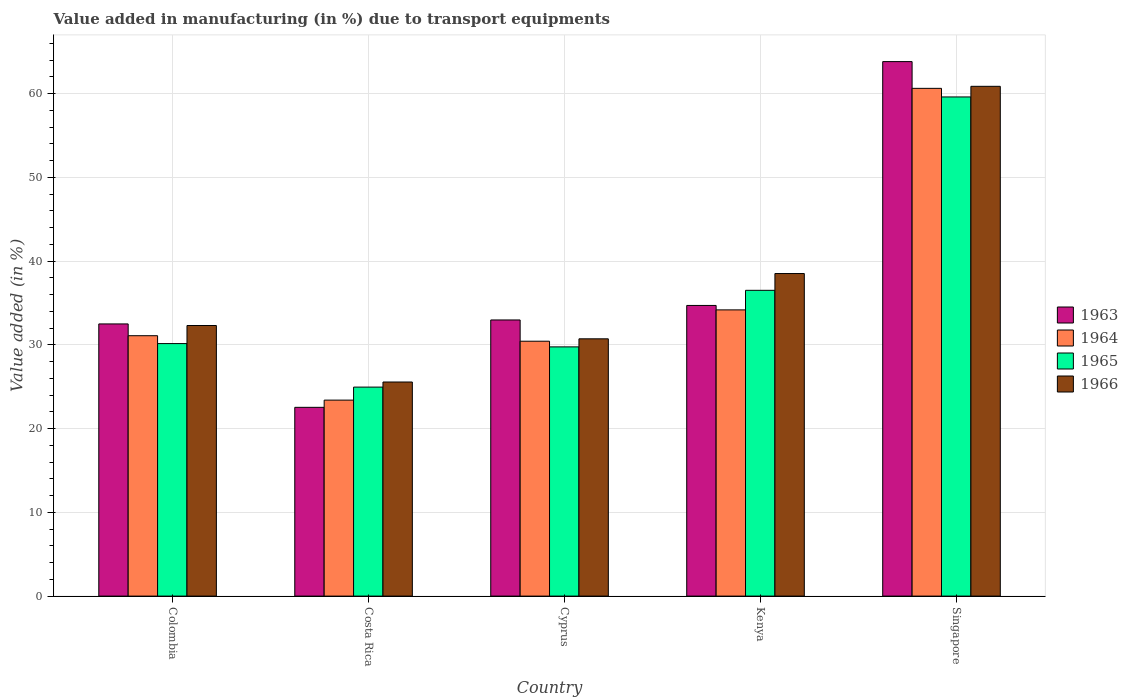How many different coloured bars are there?
Your answer should be very brief. 4. Are the number of bars per tick equal to the number of legend labels?
Provide a short and direct response. Yes. How many bars are there on the 3rd tick from the left?
Your answer should be very brief. 4. How many bars are there on the 2nd tick from the right?
Offer a very short reply. 4. What is the label of the 3rd group of bars from the left?
Your answer should be compact. Cyprus. What is the percentage of value added in manufacturing due to transport equipments in 1965 in Costa Rica?
Offer a terse response. 24.95. Across all countries, what is the maximum percentage of value added in manufacturing due to transport equipments in 1963?
Make the answer very short. 63.81. Across all countries, what is the minimum percentage of value added in manufacturing due to transport equipments in 1964?
Provide a succinct answer. 23.4. In which country was the percentage of value added in manufacturing due to transport equipments in 1963 maximum?
Provide a short and direct response. Singapore. What is the total percentage of value added in manufacturing due to transport equipments in 1966 in the graph?
Provide a succinct answer. 187.95. What is the difference between the percentage of value added in manufacturing due to transport equipments in 1966 in Costa Rica and that in Kenya?
Provide a short and direct response. -12.95. What is the difference between the percentage of value added in manufacturing due to transport equipments in 1963 in Kenya and the percentage of value added in manufacturing due to transport equipments in 1966 in Singapore?
Provide a short and direct response. -26.16. What is the average percentage of value added in manufacturing due to transport equipments in 1964 per country?
Provide a short and direct response. 35.94. What is the difference between the percentage of value added in manufacturing due to transport equipments of/in 1966 and percentage of value added in manufacturing due to transport equipments of/in 1964 in Costa Rica?
Keep it short and to the point. 2.16. What is the ratio of the percentage of value added in manufacturing due to transport equipments in 1964 in Cyprus to that in Kenya?
Offer a very short reply. 0.89. Is the difference between the percentage of value added in manufacturing due to transport equipments in 1966 in Cyprus and Singapore greater than the difference between the percentage of value added in manufacturing due to transport equipments in 1964 in Cyprus and Singapore?
Your answer should be compact. Yes. What is the difference between the highest and the second highest percentage of value added in manufacturing due to transport equipments in 1963?
Ensure brevity in your answer.  -1.73. What is the difference between the highest and the lowest percentage of value added in manufacturing due to transport equipments in 1963?
Your answer should be compact. 41.28. Is the sum of the percentage of value added in manufacturing due to transport equipments in 1963 in Colombia and Costa Rica greater than the maximum percentage of value added in manufacturing due to transport equipments in 1965 across all countries?
Give a very brief answer. No. What does the 4th bar from the left in Costa Rica represents?
Your response must be concise. 1966. What does the 2nd bar from the right in Colombia represents?
Offer a terse response. 1965. How many bars are there?
Provide a short and direct response. 20. Are all the bars in the graph horizontal?
Keep it short and to the point. No. How many countries are there in the graph?
Offer a very short reply. 5. What is the difference between two consecutive major ticks on the Y-axis?
Provide a succinct answer. 10. Are the values on the major ticks of Y-axis written in scientific E-notation?
Provide a succinct answer. No. Does the graph contain any zero values?
Your answer should be very brief. No. Where does the legend appear in the graph?
Ensure brevity in your answer.  Center right. How many legend labels are there?
Make the answer very short. 4. How are the legend labels stacked?
Provide a succinct answer. Vertical. What is the title of the graph?
Provide a succinct answer. Value added in manufacturing (in %) due to transport equipments. Does "2013" appear as one of the legend labels in the graph?
Your response must be concise. No. What is the label or title of the Y-axis?
Offer a terse response. Value added (in %). What is the Value added (in %) of 1963 in Colombia?
Provide a succinct answer. 32.49. What is the Value added (in %) in 1964 in Colombia?
Offer a very short reply. 31.09. What is the Value added (in %) in 1965 in Colombia?
Ensure brevity in your answer.  30.15. What is the Value added (in %) of 1966 in Colombia?
Ensure brevity in your answer.  32.3. What is the Value added (in %) of 1963 in Costa Rica?
Offer a terse response. 22.53. What is the Value added (in %) in 1964 in Costa Rica?
Your answer should be compact. 23.4. What is the Value added (in %) of 1965 in Costa Rica?
Make the answer very short. 24.95. What is the Value added (in %) of 1966 in Costa Rica?
Ensure brevity in your answer.  25.56. What is the Value added (in %) of 1963 in Cyprus?
Give a very brief answer. 32.97. What is the Value added (in %) in 1964 in Cyprus?
Your answer should be compact. 30.43. What is the Value added (in %) in 1965 in Cyprus?
Offer a terse response. 29.75. What is the Value added (in %) of 1966 in Cyprus?
Keep it short and to the point. 30.72. What is the Value added (in %) of 1963 in Kenya?
Ensure brevity in your answer.  34.7. What is the Value added (in %) in 1964 in Kenya?
Make the answer very short. 34.17. What is the Value added (in %) of 1965 in Kenya?
Your answer should be compact. 36.5. What is the Value added (in %) in 1966 in Kenya?
Make the answer very short. 38.51. What is the Value added (in %) of 1963 in Singapore?
Make the answer very short. 63.81. What is the Value added (in %) of 1964 in Singapore?
Make the answer very short. 60.62. What is the Value added (in %) in 1965 in Singapore?
Provide a succinct answer. 59.59. What is the Value added (in %) of 1966 in Singapore?
Ensure brevity in your answer.  60.86. Across all countries, what is the maximum Value added (in %) of 1963?
Provide a short and direct response. 63.81. Across all countries, what is the maximum Value added (in %) in 1964?
Your answer should be very brief. 60.62. Across all countries, what is the maximum Value added (in %) in 1965?
Your answer should be compact. 59.59. Across all countries, what is the maximum Value added (in %) in 1966?
Provide a short and direct response. 60.86. Across all countries, what is the minimum Value added (in %) of 1963?
Give a very brief answer. 22.53. Across all countries, what is the minimum Value added (in %) of 1964?
Offer a terse response. 23.4. Across all countries, what is the minimum Value added (in %) in 1965?
Your answer should be compact. 24.95. Across all countries, what is the minimum Value added (in %) in 1966?
Your answer should be compact. 25.56. What is the total Value added (in %) of 1963 in the graph?
Your answer should be very brief. 186.5. What is the total Value added (in %) of 1964 in the graph?
Offer a very short reply. 179.7. What is the total Value added (in %) of 1965 in the graph?
Ensure brevity in your answer.  180.94. What is the total Value added (in %) in 1966 in the graph?
Keep it short and to the point. 187.95. What is the difference between the Value added (in %) in 1963 in Colombia and that in Costa Rica?
Your answer should be very brief. 9.96. What is the difference between the Value added (in %) of 1964 in Colombia and that in Costa Rica?
Offer a terse response. 7.69. What is the difference between the Value added (in %) in 1965 in Colombia and that in Costa Rica?
Give a very brief answer. 5.2. What is the difference between the Value added (in %) in 1966 in Colombia and that in Costa Rica?
Keep it short and to the point. 6.74. What is the difference between the Value added (in %) in 1963 in Colombia and that in Cyprus?
Make the answer very short. -0.47. What is the difference between the Value added (in %) of 1964 in Colombia and that in Cyprus?
Your response must be concise. 0.66. What is the difference between the Value added (in %) in 1965 in Colombia and that in Cyprus?
Offer a terse response. 0.39. What is the difference between the Value added (in %) of 1966 in Colombia and that in Cyprus?
Offer a very short reply. 1.59. What is the difference between the Value added (in %) in 1963 in Colombia and that in Kenya?
Make the answer very short. -2.21. What is the difference between the Value added (in %) of 1964 in Colombia and that in Kenya?
Make the answer very short. -3.08. What is the difference between the Value added (in %) of 1965 in Colombia and that in Kenya?
Your answer should be very brief. -6.36. What is the difference between the Value added (in %) of 1966 in Colombia and that in Kenya?
Your answer should be compact. -6.2. What is the difference between the Value added (in %) of 1963 in Colombia and that in Singapore?
Give a very brief answer. -31.32. What is the difference between the Value added (in %) in 1964 in Colombia and that in Singapore?
Your response must be concise. -29.53. What is the difference between the Value added (in %) in 1965 in Colombia and that in Singapore?
Ensure brevity in your answer.  -29.45. What is the difference between the Value added (in %) in 1966 in Colombia and that in Singapore?
Provide a succinct answer. -28.56. What is the difference between the Value added (in %) of 1963 in Costa Rica and that in Cyprus?
Ensure brevity in your answer.  -10.43. What is the difference between the Value added (in %) in 1964 in Costa Rica and that in Cyprus?
Your answer should be compact. -7.03. What is the difference between the Value added (in %) of 1965 in Costa Rica and that in Cyprus?
Your answer should be compact. -4.8. What is the difference between the Value added (in %) of 1966 in Costa Rica and that in Cyprus?
Provide a short and direct response. -5.16. What is the difference between the Value added (in %) in 1963 in Costa Rica and that in Kenya?
Give a very brief answer. -12.17. What is the difference between the Value added (in %) in 1964 in Costa Rica and that in Kenya?
Your answer should be compact. -10.77. What is the difference between the Value added (in %) of 1965 in Costa Rica and that in Kenya?
Ensure brevity in your answer.  -11.55. What is the difference between the Value added (in %) of 1966 in Costa Rica and that in Kenya?
Provide a succinct answer. -12.95. What is the difference between the Value added (in %) of 1963 in Costa Rica and that in Singapore?
Keep it short and to the point. -41.28. What is the difference between the Value added (in %) in 1964 in Costa Rica and that in Singapore?
Ensure brevity in your answer.  -37.22. What is the difference between the Value added (in %) in 1965 in Costa Rica and that in Singapore?
Provide a short and direct response. -34.64. What is the difference between the Value added (in %) in 1966 in Costa Rica and that in Singapore?
Offer a terse response. -35.3. What is the difference between the Value added (in %) in 1963 in Cyprus and that in Kenya?
Make the answer very short. -1.73. What is the difference between the Value added (in %) in 1964 in Cyprus and that in Kenya?
Offer a very short reply. -3.74. What is the difference between the Value added (in %) of 1965 in Cyprus and that in Kenya?
Make the answer very short. -6.75. What is the difference between the Value added (in %) of 1966 in Cyprus and that in Kenya?
Provide a succinct answer. -7.79. What is the difference between the Value added (in %) in 1963 in Cyprus and that in Singapore?
Provide a succinct answer. -30.84. What is the difference between the Value added (in %) in 1964 in Cyprus and that in Singapore?
Offer a very short reply. -30.19. What is the difference between the Value added (in %) of 1965 in Cyprus and that in Singapore?
Provide a short and direct response. -29.84. What is the difference between the Value added (in %) in 1966 in Cyprus and that in Singapore?
Provide a succinct answer. -30.14. What is the difference between the Value added (in %) in 1963 in Kenya and that in Singapore?
Your answer should be very brief. -29.11. What is the difference between the Value added (in %) of 1964 in Kenya and that in Singapore?
Offer a terse response. -26.45. What is the difference between the Value added (in %) of 1965 in Kenya and that in Singapore?
Make the answer very short. -23.09. What is the difference between the Value added (in %) in 1966 in Kenya and that in Singapore?
Your answer should be very brief. -22.35. What is the difference between the Value added (in %) in 1963 in Colombia and the Value added (in %) in 1964 in Costa Rica?
Your answer should be very brief. 9.1. What is the difference between the Value added (in %) of 1963 in Colombia and the Value added (in %) of 1965 in Costa Rica?
Provide a short and direct response. 7.54. What is the difference between the Value added (in %) in 1963 in Colombia and the Value added (in %) in 1966 in Costa Rica?
Your response must be concise. 6.93. What is the difference between the Value added (in %) in 1964 in Colombia and the Value added (in %) in 1965 in Costa Rica?
Make the answer very short. 6.14. What is the difference between the Value added (in %) of 1964 in Colombia and the Value added (in %) of 1966 in Costa Rica?
Offer a very short reply. 5.53. What is the difference between the Value added (in %) in 1965 in Colombia and the Value added (in %) in 1966 in Costa Rica?
Your answer should be compact. 4.59. What is the difference between the Value added (in %) in 1963 in Colombia and the Value added (in %) in 1964 in Cyprus?
Offer a terse response. 2.06. What is the difference between the Value added (in %) in 1963 in Colombia and the Value added (in %) in 1965 in Cyprus?
Offer a terse response. 2.74. What is the difference between the Value added (in %) of 1963 in Colombia and the Value added (in %) of 1966 in Cyprus?
Offer a terse response. 1.78. What is the difference between the Value added (in %) of 1964 in Colombia and the Value added (in %) of 1965 in Cyprus?
Ensure brevity in your answer.  1.33. What is the difference between the Value added (in %) of 1964 in Colombia and the Value added (in %) of 1966 in Cyprus?
Keep it short and to the point. 0.37. What is the difference between the Value added (in %) in 1965 in Colombia and the Value added (in %) in 1966 in Cyprus?
Offer a terse response. -0.57. What is the difference between the Value added (in %) of 1963 in Colombia and the Value added (in %) of 1964 in Kenya?
Offer a terse response. -1.68. What is the difference between the Value added (in %) in 1963 in Colombia and the Value added (in %) in 1965 in Kenya?
Provide a short and direct response. -4.01. What is the difference between the Value added (in %) in 1963 in Colombia and the Value added (in %) in 1966 in Kenya?
Keep it short and to the point. -6.01. What is the difference between the Value added (in %) of 1964 in Colombia and the Value added (in %) of 1965 in Kenya?
Ensure brevity in your answer.  -5.42. What is the difference between the Value added (in %) in 1964 in Colombia and the Value added (in %) in 1966 in Kenya?
Your answer should be very brief. -7.42. What is the difference between the Value added (in %) in 1965 in Colombia and the Value added (in %) in 1966 in Kenya?
Your response must be concise. -8.36. What is the difference between the Value added (in %) in 1963 in Colombia and the Value added (in %) in 1964 in Singapore?
Offer a very short reply. -28.12. What is the difference between the Value added (in %) of 1963 in Colombia and the Value added (in %) of 1965 in Singapore?
Offer a very short reply. -27.1. What is the difference between the Value added (in %) of 1963 in Colombia and the Value added (in %) of 1966 in Singapore?
Offer a very short reply. -28.37. What is the difference between the Value added (in %) in 1964 in Colombia and the Value added (in %) in 1965 in Singapore?
Your response must be concise. -28.51. What is the difference between the Value added (in %) in 1964 in Colombia and the Value added (in %) in 1966 in Singapore?
Your response must be concise. -29.77. What is the difference between the Value added (in %) in 1965 in Colombia and the Value added (in %) in 1966 in Singapore?
Provide a succinct answer. -30.71. What is the difference between the Value added (in %) in 1963 in Costa Rica and the Value added (in %) in 1964 in Cyprus?
Your answer should be very brief. -7.9. What is the difference between the Value added (in %) in 1963 in Costa Rica and the Value added (in %) in 1965 in Cyprus?
Offer a very short reply. -7.22. What is the difference between the Value added (in %) of 1963 in Costa Rica and the Value added (in %) of 1966 in Cyprus?
Provide a succinct answer. -8.18. What is the difference between the Value added (in %) in 1964 in Costa Rica and the Value added (in %) in 1965 in Cyprus?
Provide a short and direct response. -6.36. What is the difference between the Value added (in %) of 1964 in Costa Rica and the Value added (in %) of 1966 in Cyprus?
Keep it short and to the point. -7.32. What is the difference between the Value added (in %) in 1965 in Costa Rica and the Value added (in %) in 1966 in Cyprus?
Give a very brief answer. -5.77. What is the difference between the Value added (in %) in 1963 in Costa Rica and the Value added (in %) in 1964 in Kenya?
Offer a terse response. -11.64. What is the difference between the Value added (in %) in 1963 in Costa Rica and the Value added (in %) in 1965 in Kenya?
Make the answer very short. -13.97. What is the difference between the Value added (in %) in 1963 in Costa Rica and the Value added (in %) in 1966 in Kenya?
Provide a short and direct response. -15.97. What is the difference between the Value added (in %) of 1964 in Costa Rica and the Value added (in %) of 1965 in Kenya?
Your answer should be compact. -13.11. What is the difference between the Value added (in %) in 1964 in Costa Rica and the Value added (in %) in 1966 in Kenya?
Ensure brevity in your answer.  -15.11. What is the difference between the Value added (in %) of 1965 in Costa Rica and the Value added (in %) of 1966 in Kenya?
Make the answer very short. -13.56. What is the difference between the Value added (in %) of 1963 in Costa Rica and the Value added (in %) of 1964 in Singapore?
Provide a short and direct response. -38.08. What is the difference between the Value added (in %) of 1963 in Costa Rica and the Value added (in %) of 1965 in Singapore?
Offer a terse response. -37.06. What is the difference between the Value added (in %) of 1963 in Costa Rica and the Value added (in %) of 1966 in Singapore?
Offer a very short reply. -38.33. What is the difference between the Value added (in %) of 1964 in Costa Rica and the Value added (in %) of 1965 in Singapore?
Offer a very short reply. -36.19. What is the difference between the Value added (in %) of 1964 in Costa Rica and the Value added (in %) of 1966 in Singapore?
Offer a terse response. -37.46. What is the difference between the Value added (in %) of 1965 in Costa Rica and the Value added (in %) of 1966 in Singapore?
Provide a short and direct response. -35.91. What is the difference between the Value added (in %) of 1963 in Cyprus and the Value added (in %) of 1964 in Kenya?
Your response must be concise. -1.2. What is the difference between the Value added (in %) in 1963 in Cyprus and the Value added (in %) in 1965 in Kenya?
Make the answer very short. -3.54. What is the difference between the Value added (in %) in 1963 in Cyprus and the Value added (in %) in 1966 in Kenya?
Give a very brief answer. -5.54. What is the difference between the Value added (in %) of 1964 in Cyprus and the Value added (in %) of 1965 in Kenya?
Offer a terse response. -6.07. What is the difference between the Value added (in %) in 1964 in Cyprus and the Value added (in %) in 1966 in Kenya?
Offer a very short reply. -8.08. What is the difference between the Value added (in %) of 1965 in Cyprus and the Value added (in %) of 1966 in Kenya?
Your answer should be very brief. -8.75. What is the difference between the Value added (in %) of 1963 in Cyprus and the Value added (in %) of 1964 in Singapore?
Ensure brevity in your answer.  -27.65. What is the difference between the Value added (in %) in 1963 in Cyprus and the Value added (in %) in 1965 in Singapore?
Ensure brevity in your answer.  -26.62. What is the difference between the Value added (in %) in 1963 in Cyprus and the Value added (in %) in 1966 in Singapore?
Your answer should be compact. -27.89. What is the difference between the Value added (in %) of 1964 in Cyprus and the Value added (in %) of 1965 in Singapore?
Your answer should be very brief. -29.16. What is the difference between the Value added (in %) in 1964 in Cyprus and the Value added (in %) in 1966 in Singapore?
Give a very brief answer. -30.43. What is the difference between the Value added (in %) of 1965 in Cyprus and the Value added (in %) of 1966 in Singapore?
Your response must be concise. -31.11. What is the difference between the Value added (in %) of 1963 in Kenya and the Value added (in %) of 1964 in Singapore?
Keep it short and to the point. -25.92. What is the difference between the Value added (in %) of 1963 in Kenya and the Value added (in %) of 1965 in Singapore?
Offer a very short reply. -24.89. What is the difference between the Value added (in %) in 1963 in Kenya and the Value added (in %) in 1966 in Singapore?
Your answer should be compact. -26.16. What is the difference between the Value added (in %) of 1964 in Kenya and the Value added (in %) of 1965 in Singapore?
Give a very brief answer. -25.42. What is the difference between the Value added (in %) in 1964 in Kenya and the Value added (in %) in 1966 in Singapore?
Your answer should be compact. -26.69. What is the difference between the Value added (in %) in 1965 in Kenya and the Value added (in %) in 1966 in Singapore?
Make the answer very short. -24.36. What is the average Value added (in %) of 1963 per country?
Provide a short and direct response. 37.3. What is the average Value added (in %) in 1964 per country?
Provide a short and direct response. 35.94. What is the average Value added (in %) in 1965 per country?
Offer a very short reply. 36.19. What is the average Value added (in %) in 1966 per country?
Your response must be concise. 37.59. What is the difference between the Value added (in %) of 1963 and Value added (in %) of 1964 in Colombia?
Your answer should be compact. 1.41. What is the difference between the Value added (in %) of 1963 and Value added (in %) of 1965 in Colombia?
Your response must be concise. 2.35. What is the difference between the Value added (in %) of 1963 and Value added (in %) of 1966 in Colombia?
Offer a terse response. 0.19. What is the difference between the Value added (in %) in 1964 and Value added (in %) in 1965 in Colombia?
Give a very brief answer. 0.94. What is the difference between the Value added (in %) in 1964 and Value added (in %) in 1966 in Colombia?
Your answer should be very brief. -1.22. What is the difference between the Value added (in %) in 1965 and Value added (in %) in 1966 in Colombia?
Ensure brevity in your answer.  -2.16. What is the difference between the Value added (in %) of 1963 and Value added (in %) of 1964 in Costa Rica?
Keep it short and to the point. -0.86. What is the difference between the Value added (in %) in 1963 and Value added (in %) in 1965 in Costa Rica?
Provide a short and direct response. -2.42. What is the difference between the Value added (in %) of 1963 and Value added (in %) of 1966 in Costa Rica?
Keep it short and to the point. -3.03. What is the difference between the Value added (in %) in 1964 and Value added (in %) in 1965 in Costa Rica?
Your answer should be compact. -1.55. What is the difference between the Value added (in %) of 1964 and Value added (in %) of 1966 in Costa Rica?
Offer a terse response. -2.16. What is the difference between the Value added (in %) in 1965 and Value added (in %) in 1966 in Costa Rica?
Offer a very short reply. -0.61. What is the difference between the Value added (in %) of 1963 and Value added (in %) of 1964 in Cyprus?
Make the answer very short. 2.54. What is the difference between the Value added (in %) of 1963 and Value added (in %) of 1965 in Cyprus?
Provide a short and direct response. 3.21. What is the difference between the Value added (in %) of 1963 and Value added (in %) of 1966 in Cyprus?
Make the answer very short. 2.25. What is the difference between the Value added (in %) of 1964 and Value added (in %) of 1965 in Cyprus?
Make the answer very short. 0.68. What is the difference between the Value added (in %) of 1964 and Value added (in %) of 1966 in Cyprus?
Offer a terse response. -0.29. What is the difference between the Value added (in %) of 1965 and Value added (in %) of 1966 in Cyprus?
Provide a succinct answer. -0.96. What is the difference between the Value added (in %) in 1963 and Value added (in %) in 1964 in Kenya?
Your answer should be compact. 0.53. What is the difference between the Value added (in %) in 1963 and Value added (in %) in 1965 in Kenya?
Make the answer very short. -1.8. What is the difference between the Value added (in %) of 1963 and Value added (in %) of 1966 in Kenya?
Your answer should be compact. -3.81. What is the difference between the Value added (in %) in 1964 and Value added (in %) in 1965 in Kenya?
Your answer should be very brief. -2.33. What is the difference between the Value added (in %) of 1964 and Value added (in %) of 1966 in Kenya?
Offer a terse response. -4.34. What is the difference between the Value added (in %) in 1965 and Value added (in %) in 1966 in Kenya?
Ensure brevity in your answer.  -2. What is the difference between the Value added (in %) in 1963 and Value added (in %) in 1964 in Singapore?
Provide a short and direct response. 3.19. What is the difference between the Value added (in %) in 1963 and Value added (in %) in 1965 in Singapore?
Provide a short and direct response. 4.22. What is the difference between the Value added (in %) of 1963 and Value added (in %) of 1966 in Singapore?
Give a very brief answer. 2.95. What is the difference between the Value added (in %) in 1964 and Value added (in %) in 1965 in Singapore?
Provide a succinct answer. 1.03. What is the difference between the Value added (in %) of 1964 and Value added (in %) of 1966 in Singapore?
Give a very brief answer. -0.24. What is the difference between the Value added (in %) of 1965 and Value added (in %) of 1966 in Singapore?
Provide a short and direct response. -1.27. What is the ratio of the Value added (in %) of 1963 in Colombia to that in Costa Rica?
Your answer should be very brief. 1.44. What is the ratio of the Value added (in %) in 1964 in Colombia to that in Costa Rica?
Keep it short and to the point. 1.33. What is the ratio of the Value added (in %) of 1965 in Colombia to that in Costa Rica?
Provide a succinct answer. 1.21. What is the ratio of the Value added (in %) of 1966 in Colombia to that in Costa Rica?
Give a very brief answer. 1.26. What is the ratio of the Value added (in %) of 1963 in Colombia to that in Cyprus?
Keep it short and to the point. 0.99. What is the ratio of the Value added (in %) of 1964 in Colombia to that in Cyprus?
Your answer should be compact. 1.02. What is the ratio of the Value added (in %) of 1965 in Colombia to that in Cyprus?
Make the answer very short. 1.01. What is the ratio of the Value added (in %) in 1966 in Colombia to that in Cyprus?
Keep it short and to the point. 1.05. What is the ratio of the Value added (in %) of 1963 in Colombia to that in Kenya?
Your answer should be very brief. 0.94. What is the ratio of the Value added (in %) of 1964 in Colombia to that in Kenya?
Offer a very short reply. 0.91. What is the ratio of the Value added (in %) in 1965 in Colombia to that in Kenya?
Give a very brief answer. 0.83. What is the ratio of the Value added (in %) in 1966 in Colombia to that in Kenya?
Ensure brevity in your answer.  0.84. What is the ratio of the Value added (in %) of 1963 in Colombia to that in Singapore?
Provide a short and direct response. 0.51. What is the ratio of the Value added (in %) in 1964 in Colombia to that in Singapore?
Give a very brief answer. 0.51. What is the ratio of the Value added (in %) of 1965 in Colombia to that in Singapore?
Keep it short and to the point. 0.51. What is the ratio of the Value added (in %) of 1966 in Colombia to that in Singapore?
Your answer should be very brief. 0.53. What is the ratio of the Value added (in %) in 1963 in Costa Rica to that in Cyprus?
Your answer should be very brief. 0.68. What is the ratio of the Value added (in %) of 1964 in Costa Rica to that in Cyprus?
Make the answer very short. 0.77. What is the ratio of the Value added (in %) in 1965 in Costa Rica to that in Cyprus?
Your answer should be very brief. 0.84. What is the ratio of the Value added (in %) of 1966 in Costa Rica to that in Cyprus?
Give a very brief answer. 0.83. What is the ratio of the Value added (in %) of 1963 in Costa Rica to that in Kenya?
Offer a terse response. 0.65. What is the ratio of the Value added (in %) of 1964 in Costa Rica to that in Kenya?
Your answer should be compact. 0.68. What is the ratio of the Value added (in %) in 1965 in Costa Rica to that in Kenya?
Provide a succinct answer. 0.68. What is the ratio of the Value added (in %) of 1966 in Costa Rica to that in Kenya?
Offer a terse response. 0.66. What is the ratio of the Value added (in %) of 1963 in Costa Rica to that in Singapore?
Provide a short and direct response. 0.35. What is the ratio of the Value added (in %) in 1964 in Costa Rica to that in Singapore?
Ensure brevity in your answer.  0.39. What is the ratio of the Value added (in %) in 1965 in Costa Rica to that in Singapore?
Give a very brief answer. 0.42. What is the ratio of the Value added (in %) in 1966 in Costa Rica to that in Singapore?
Provide a short and direct response. 0.42. What is the ratio of the Value added (in %) in 1963 in Cyprus to that in Kenya?
Give a very brief answer. 0.95. What is the ratio of the Value added (in %) in 1964 in Cyprus to that in Kenya?
Offer a terse response. 0.89. What is the ratio of the Value added (in %) in 1965 in Cyprus to that in Kenya?
Your answer should be very brief. 0.82. What is the ratio of the Value added (in %) in 1966 in Cyprus to that in Kenya?
Provide a succinct answer. 0.8. What is the ratio of the Value added (in %) in 1963 in Cyprus to that in Singapore?
Offer a very short reply. 0.52. What is the ratio of the Value added (in %) in 1964 in Cyprus to that in Singapore?
Keep it short and to the point. 0.5. What is the ratio of the Value added (in %) of 1965 in Cyprus to that in Singapore?
Your response must be concise. 0.5. What is the ratio of the Value added (in %) of 1966 in Cyprus to that in Singapore?
Give a very brief answer. 0.5. What is the ratio of the Value added (in %) in 1963 in Kenya to that in Singapore?
Offer a very short reply. 0.54. What is the ratio of the Value added (in %) in 1964 in Kenya to that in Singapore?
Your answer should be compact. 0.56. What is the ratio of the Value added (in %) in 1965 in Kenya to that in Singapore?
Offer a terse response. 0.61. What is the ratio of the Value added (in %) in 1966 in Kenya to that in Singapore?
Give a very brief answer. 0.63. What is the difference between the highest and the second highest Value added (in %) of 1963?
Your answer should be compact. 29.11. What is the difference between the highest and the second highest Value added (in %) of 1964?
Ensure brevity in your answer.  26.45. What is the difference between the highest and the second highest Value added (in %) of 1965?
Ensure brevity in your answer.  23.09. What is the difference between the highest and the second highest Value added (in %) of 1966?
Your response must be concise. 22.35. What is the difference between the highest and the lowest Value added (in %) in 1963?
Give a very brief answer. 41.28. What is the difference between the highest and the lowest Value added (in %) of 1964?
Ensure brevity in your answer.  37.22. What is the difference between the highest and the lowest Value added (in %) of 1965?
Offer a terse response. 34.64. What is the difference between the highest and the lowest Value added (in %) in 1966?
Provide a succinct answer. 35.3. 